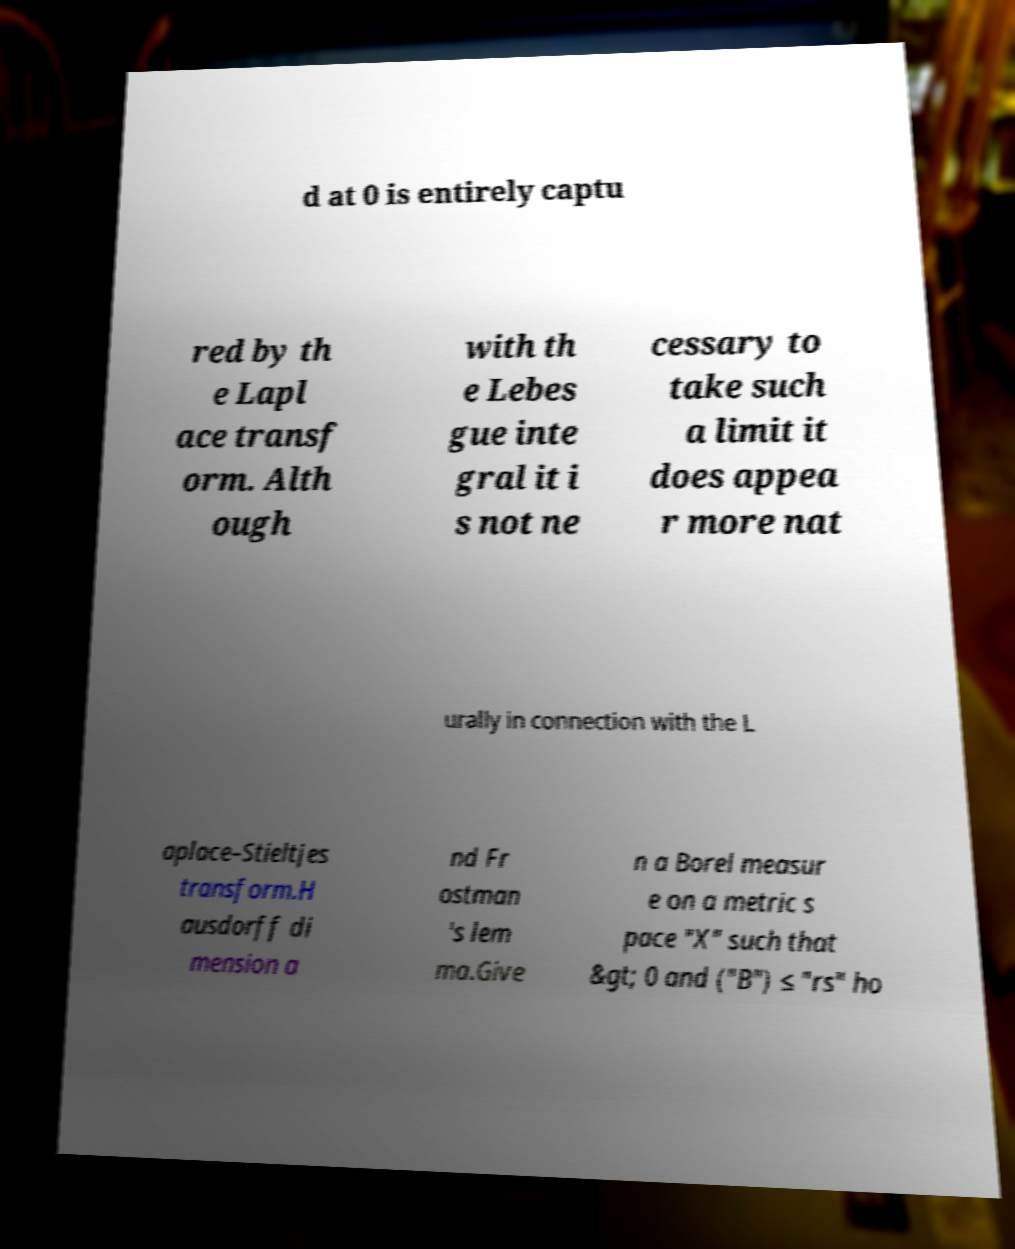Could you assist in decoding the text presented in this image and type it out clearly? d at 0 is entirely captu red by th e Lapl ace transf orm. Alth ough with th e Lebes gue inte gral it i s not ne cessary to take such a limit it does appea r more nat urally in connection with the L aplace–Stieltjes transform.H ausdorff di mension a nd Fr ostman 's lem ma.Give n a Borel measur e on a metric s pace "X" such that &gt; 0 and ("B") ≤ "rs" ho 